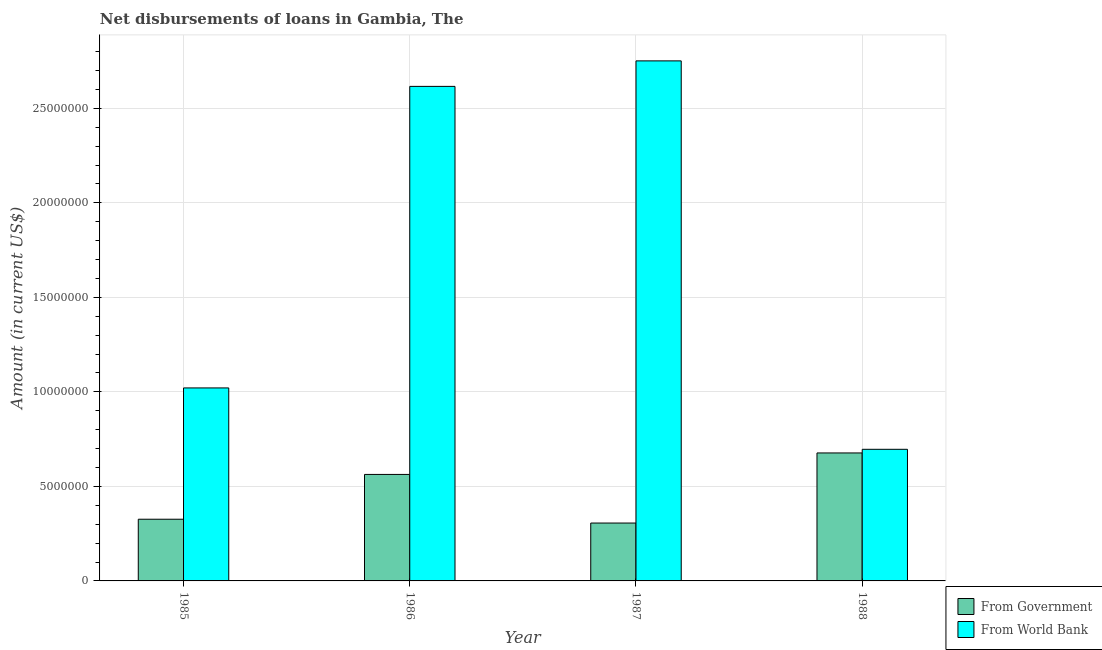How many different coloured bars are there?
Keep it short and to the point. 2. Are the number of bars per tick equal to the number of legend labels?
Offer a very short reply. Yes. Are the number of bars on each tick of the X-axis equal?
Your answer should be very brief. Yes. In how many cases, is the number of bars for a given year not equal to the number of legend labels?
Your answer should be very brief. 0. What is the net disbursements of loan from government in 1988?
Offer a very short reply. 6.77e+06. Across all years, what is the maximum net disbursements of loan from government?
Offer a very short reply. 6.77e+06. Across all years, what is the minimum net disbursements of loan from government?
Keep it short and to the point. 3.06e+06. In which year was the net disbursements of loan from world bank maximum?
Provide a succinct answer. 1987. In which year was the net disbursements of loan from world bank minimum?
Make the answer very short. 1988. What is the total net disbursements of loan from government in the graph?
Provide a succinct answer. 1.87e+07. What is the difference between the net disbursements of loan from government in 1985 and that in 1988?
Your response must be concise. -3.51e+06. What is the difference between the net disbursements of loan from government in 1985 and the net disbursements of loan from world bank in 1987?
Provide a short and direct response. 2.01e+05. What is the average net disbursements of loan from government per year?
Make the answer very short. 4.68e+06. What is the ratio of the net disbursements of loan from world bank in 1986 to that in 1987?
Give a very brief answer. 0.95. What is the difference between the highest and the second highest net disbursements of loan from world bank?
Your answer should be very brief. 1.35e+06. What is the difference between the highest and the lowest net disbursements of loan from world bank?
Make the answer very short. 2.05e+07. In how many years, is the net disbursements of loan from government greater than the average net disbursements of loan from government taken over all years?
Offer a terse response. 2. Is the sum of the net disbursements of loan from government in 1986 and 1987 greater than the maximum net disbursements of loan from world bank across all years?
Offer a very short reply. Yes. What does the 2nd bar from the left in 1985 represents?
Your answer should be compact. From World Bank. What does the 2nd bar from the right in 1987 represents?
Offer a terse response. From Government. Where does the legend appear in the graph?
Offer a very short reply. Bottom right. What is the title of the graph?
Ensure brevity in your answer.  Net disbursements of loans in Gambia, The. What is the Amount (in current US$) in From Government in 1985?
Your answer should be compact. 3.26e+06. What is the Amount (in current US$) of From World Bank in 1985?
Offer a terse response. 1.02e+07. What is the Amount (in current US$) in From Government in 1986?
Provide a succinct answer. 5.63e+06. What is the Amount (in current US$) in From World Bank in 1986?
Provide a succinct answer. 2.62e+07. What is the Amount (in current US$) of From Government in 1987?
Offer a very short reply. 3.06e+06. What is the Amount (in current US$) of From World Bank in 1987?
Ensure brevity in your answer.  2.75e+07. What is the Amount (in current US$) of From Government in 1988?
Provide a succinct answer. 6.77e+06. What is the Amount (in current US$) in From World Bank in 1988?
Give a very brief answer. 6.96e+06. Across all years, what is the maximum Amount (in current US$) in From Government?
Give a very brief answer. 6.77e+06. Across all years, what is the maximum Amount (in current US$) in From World Bank?
Offer a very short reply. 2.75e+07. Across all years, what is the minimum Amount (in current US$) of From Government?
Your answer should be compact. 3.06e+06. Across all years, what is the minimum Amount (in current US$) of From World Bank?
Ensure brevity in your answer.  6.96e+06. What is the total Amount (in current US$) in From Government in the graph?
Your answer should be compact. 1.87e+07. What is the total Amount (in current US$) of From World Bank in the graph?
Your answer should be very brief. 7.08e+07. What is the difference between the Amount (in current US$) in From Government in 1985 and that in 1986?
Make the answer very short. -2.37e+06. What is the difference between the Amount (in current US$) of From World Bank in 1985 and that in 1986?
Your answer should be compact. -1.60e+07. What is the difference between the Amount (in current US$) of From Government in 1985 and that in 1987?
Your response must be concise. 2.01e+05. What is the difference between the Amount (in current US$) of From World Bank in 1985 and that in 1987?
Offer a very short reply. -1.73e+07. What is the difference between the Amount (in current US$) of From Government in 1985 and that in 1988?
Your answer should be very brief. -3.51e+06. What is the difference between the Amount (in current US$) in From World Bank in 1985 and that in 1988?
Make the answer very short. 3.25e+06. What is the difference between the Amount (in current US$) in From Government in 1986 and that in 1987?
Offer a terse response. 2.57e+06. What is the difference between the Amount (in current US$) in From World Bank in 1986 and that in 1987?
Provide a succinct answer. -1.35e+06. What is the difference between the Amount (in current US$) in From Government in 1986 and that in 1988?
Offer a very short reply. -1.14e+06. What is the difference between the Amount (in current US$) in From World Bank in 1986 and that in 1988?
Ensure brevity in your answer.  1.92e+07. What is the difference between the Amount (in current US$) of From Government in 1987 and that in 1988?
Your answer should be compact. -3.71e+06. What is the difference between the Amount (in current US$) of From World Bank in 1987 and that in 1988?
Your answer should be very brief. 2.05e+07. What is the difference between the Amount (in current US$) of From Government in 1985 and the Amount (in current US$) of From World Bank in 1986?
Give a very brief answer. -2.29e+07. What is the difference between the Amount (in current US$) in From Government in 1985 and the Amount (in current US$) in From World Bank in 1987?
Provide a succinct answer. -2.42e+07. What is the difference between the Amount (in current US$) in From Government in 1985 and the Amount (in current US$) in From World Bank in 1988?
Make the answer very short. -3.70e+06. What is the difference between the Amount (in current US$) of From Government in 1986 and the Amount (in current US$) of From World Bank in 1987?
Your response must be concise. -2.19e+07. What is the difference between the Amount (in current US$) in From Government in 1986 and the Amount (in current US$) in From World Bank in 1988?
Your answer should be compact. -1.33e+06. What is the difference between the Amount (in current US$) in From Government in 1987 and the Amount (in current US$) in From World Bank in 1988?
Ensure brevity in your answer.  -3.90e+06. What is the average Amount (in current US$) of From Government per year?
Your answer should be compact. 4.68e+06. What is the average Amount (in current US$) in From World Bank per year?
Make the answer very short. 1.77e+07. In the year 1985, what is the difference between the Amount (in current US$) of From Government and Amount (in current US$) of From World Bank?
Your answer should be compact. -6.94e+06. In the year 1986, what is the difference between the Amount (in current US$) in From Government and Amount (in current US$) in From World Bank?
Offer a terse response. -2.05e+07. In the year 1987, what is the difference between the Amount (in current US$) of From Government and Amount (in current US$) of From World Bank?
Your answer should be compact. -2.44e+07. In the year 1988, what is the difference between the Amount (in current US$) of From Government and Amount (in current US$) of From World Bank?
Give a very brief answer. -1.93e+05. What is the ratio of the Amount (in current US$) in From Government in 1985 to that in 1986?
Offer a terse response. 0.58. What is the ratio of the Amount (in current US$) in From World Bank in 1985 to that in 1986?
Provide a short and direct response. 0.39. What is the ratio of the Amount (in current US$) of From Government in 1985 to that in 1987?
Provide a succinct answer. 1.07. What is the ratio of the Amount (in current US$) in From World Bank in 1985 to that in 1987?
Offer a very short reply. 0.37. What is the ratio of the Amount (in current US$) of From Government in 1985 to that in 1988?
Your answer should be compact. 0.48. What is the ratio of the Amount (in current US$) of From World Bank in 1985 to that in 1988?
Ensure brevity in your answer.  1.47. What is the ratio of the Amount (in current US$) of From Government in 1986 to that in 1987?
Your response must be concise. 1.84. What is the ratio of the Amount (in current US$) of From World Bank in 1986 to that in 1987?
Your answer should be compact. 0.95. What is the ratio of the Amount (in current US$) in From Government in 1986 to that in 1988?
Offer a terse response. 0.83. What is the ratio of the Amount (in current US$) in From World Bank in 1986 to that in 1988?
Make the answer very short. 3.76. What is the ratio of the Amount (in current US$) of From Government in 1987 to that in 1988?
Your response must be concise. 0.45. What is the ratio of the Amount (in current US$) in From World Bank in 1987 to that in 1988?
Offer a terse response. 3.95. What is the difference between the highest and the second highest Amount (in current US$) of From Government?
Ensure brevity in your answer.  1.14e+06. What is the difference between the highest and the second highest Amount (in current US$) of From World Bank?
Offer a very short reply. 1.35e+06. What is the difference between the highest and the lowest Amount (in current US$) of From Government?
Make the answer very short. 3.71e+06. What is the difference between the highest and the lowest Amount (in current US$) of From World Bank?
Your answer should be very brief. 2.05e+07. 